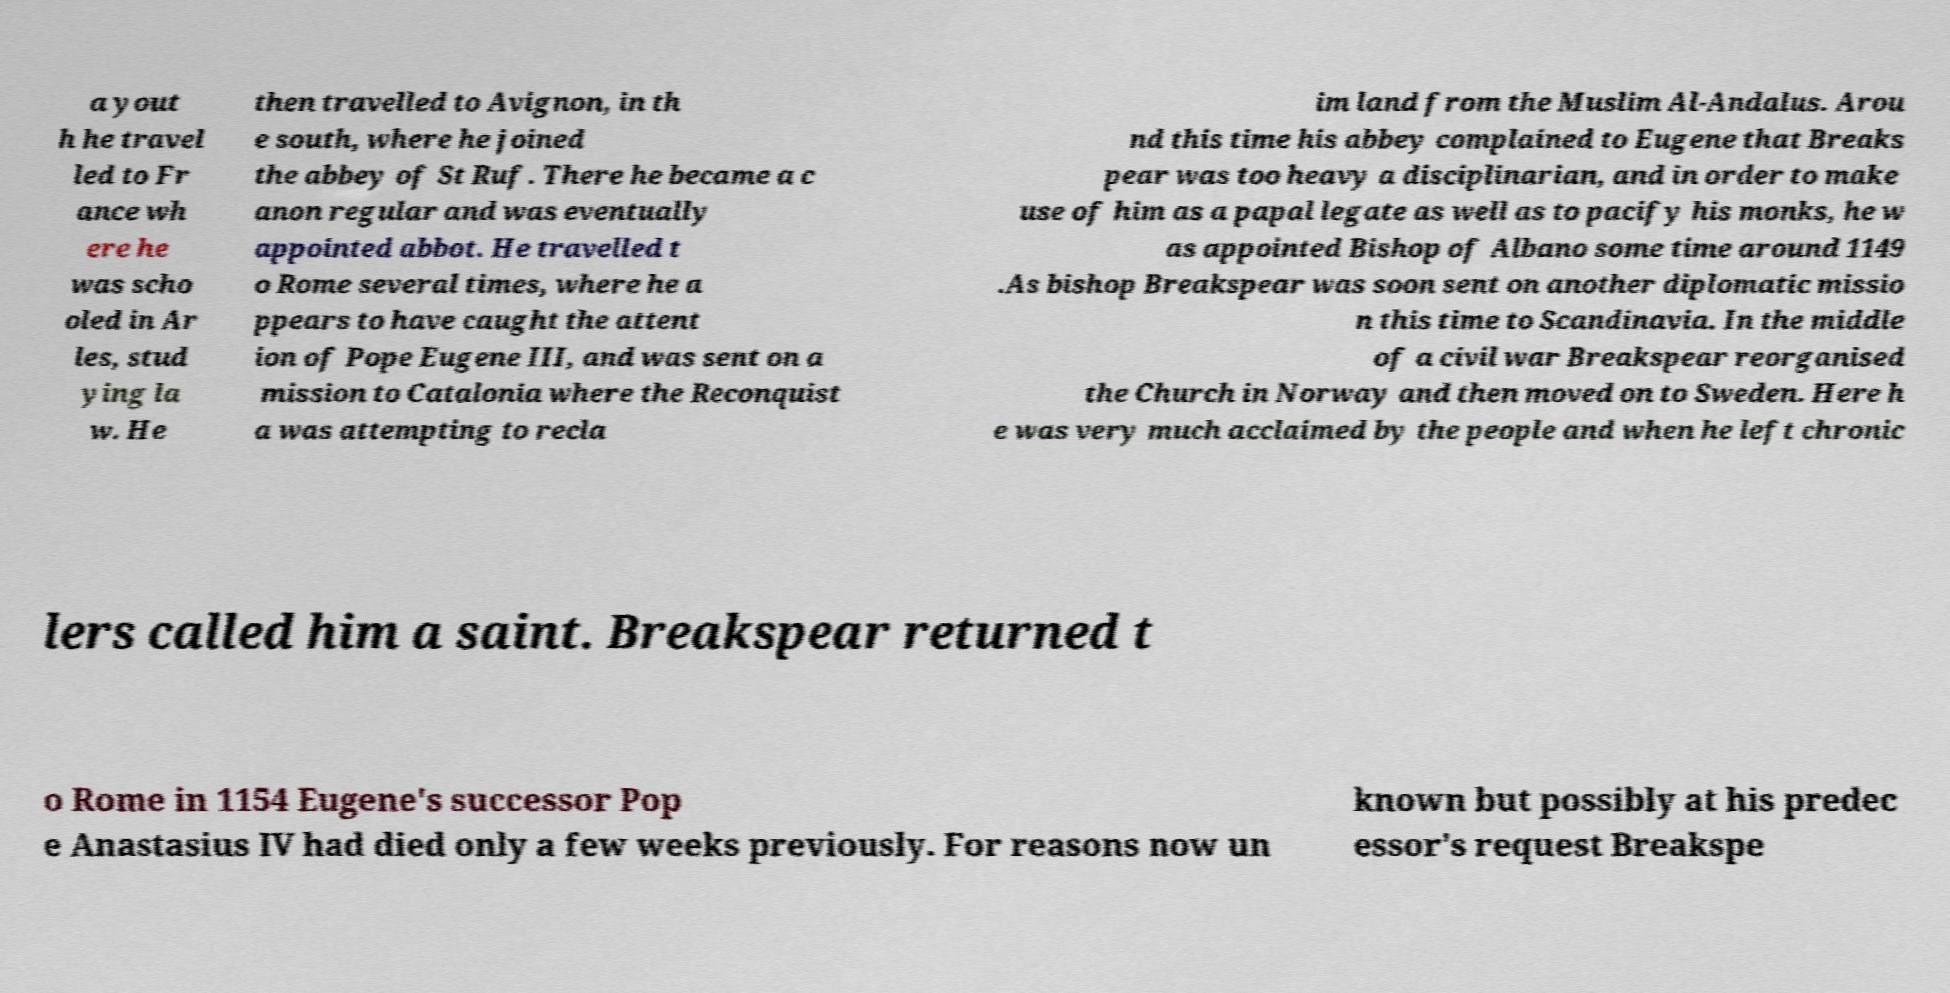Please read and relay the text visible in this image. What does it say? a yout h he travel led to Fr ance wh ere he was scho oled in Ar les, stud ying la w. He then travelled to Avignon, in th e south, where he joined the abbey of St Ruf. There he became a c anon regular and was eventually appointed abbot. He travelled t o Rome several times, where he a ppears to have caught the attent ion of Pope Eugene III, and was sent on a mission to Catalonia where the Reconquist a was attempting to recla im land from the Muslim Al-Andalus. Arou nd this time his abbey complained to Eugene that Breaks pear was too heavy a disciplinarian, and in order to make use of him as a papal legate as well as to pacify his monks, he w as appointed Bishop of Albano some time around 1149 .As bishop Breakspear was soon sent on another diplomatic missio n this time to Scandinavia. In the middle of a civil war Breakspear reorganised the Church in Norway and then moved on to Sweden. Here h e was very much acclaimed by the people and when he left chronic lers called him a saint. Breakspear returned t o Rome in 1154 Eugene's successor Pop e Anastasius IV had died only a few weeks previously. For reasons now un known but possibly at his predec essor's request Breakspe 